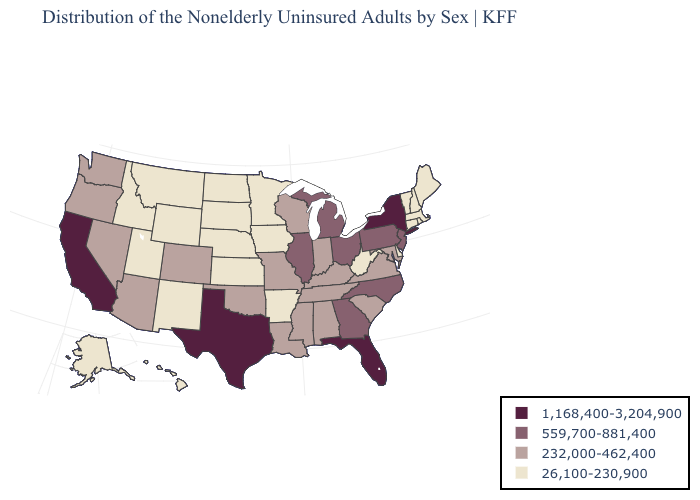What is the value of North Carolina?
Give a very brief answer. 559,700-881,400. Is the legend a continuous bar?
Be succinct. No. Does New Mexico have the lowest value in the USA?
Short answer required. Yes. Name the states that have a value in the range 1,168,400-3,204,900?
Write a very short answer. California, Florida, New York, Texas. What is the value of Virginia?
Quick response, please. 232,000-462,400. What is the lowest value in the South?
Short answer required. 26,100-230,900. Is the legend a continuous bar?
Short answer required. No. Name the states that have a value in the range 559,700-881,400?
Be succinct. Georgia, Illinois, Michigan, New Jersey, North Carolina, Ohio, Pennsylvania. Name the states that have a value in the range 26,100-230,900?
Give a very brief answer. Alaska, Arkansas, Connecticut, Delaware, Hawaii, Idaho, Iowa, Kansas, Maine, Massachusetts, Minnesota, Montana, Nebraska, New Hampshire, New Mexico, North Dakota, Rhode Island, South Dakota, Utah, Vermont, West Virginia, Wyoming. Among the states that border California , which have the lowest value?
Give a very brief answer. Arizona, Nevada, Oregon. Which states have the lowest value in the MidWest?
Quick response, please. Iowa, Kansas, Minnesota, Nebraska, North Dakota, South Dakota. Does the map have missing data?
Concise answer only. No. Which states have the lowest value in the USA?
Write a very short answer. Alaska, Arkansas, Connecticut, Delaware, Hawaii, Idaho, Iowa, Kansas, Maine, Massachusetts, Minnesota, Montana, Nebraska, New Hampshire, New Mexico, North Dakota, Rhode Island, South Dakota, Utah, Vermont, West Virginia, Wyoming. Which states have the lowest value in the Northeast?
Keep it brief. Connecticut, Maine, Massachusetts, New Hampshire, Rhode Island, Vermont. What is the highest value in states that border Mississippi?
Keep it brief. 232,000-462,400. 